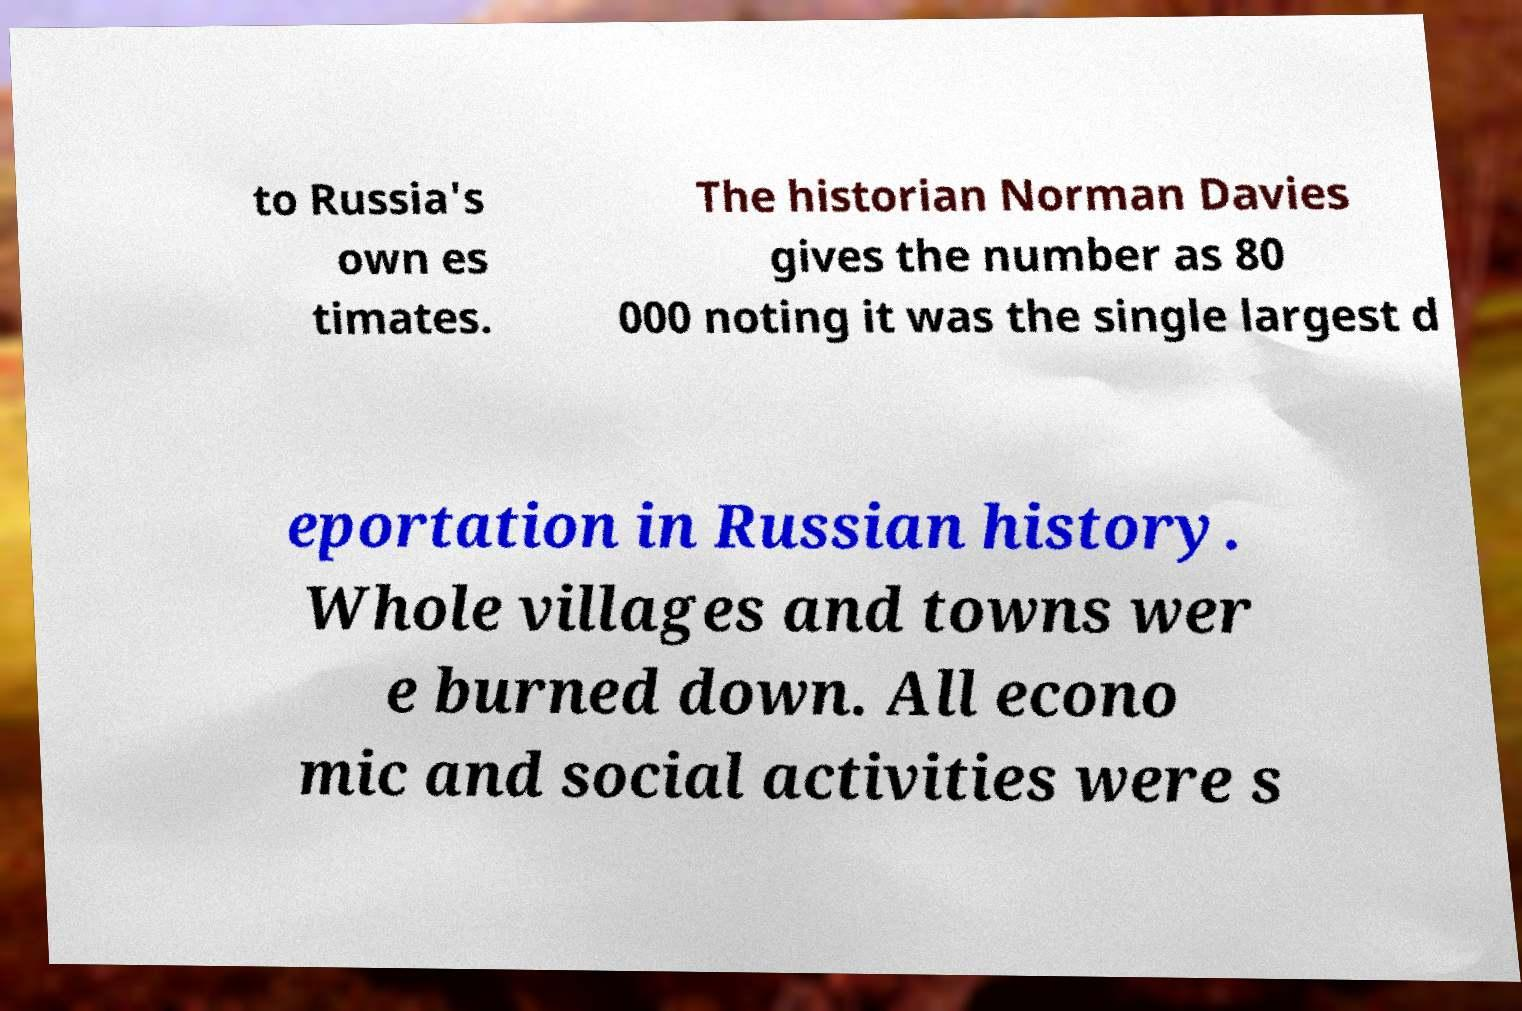Could you extract and type out the text from this image? to Russia's own es timates. The historian Norman Davies gives the number as 80 000 noting it was the single largest d eportation in Russian history. Whole villages and towns wer e burned down. All econo mic and social activities were s 